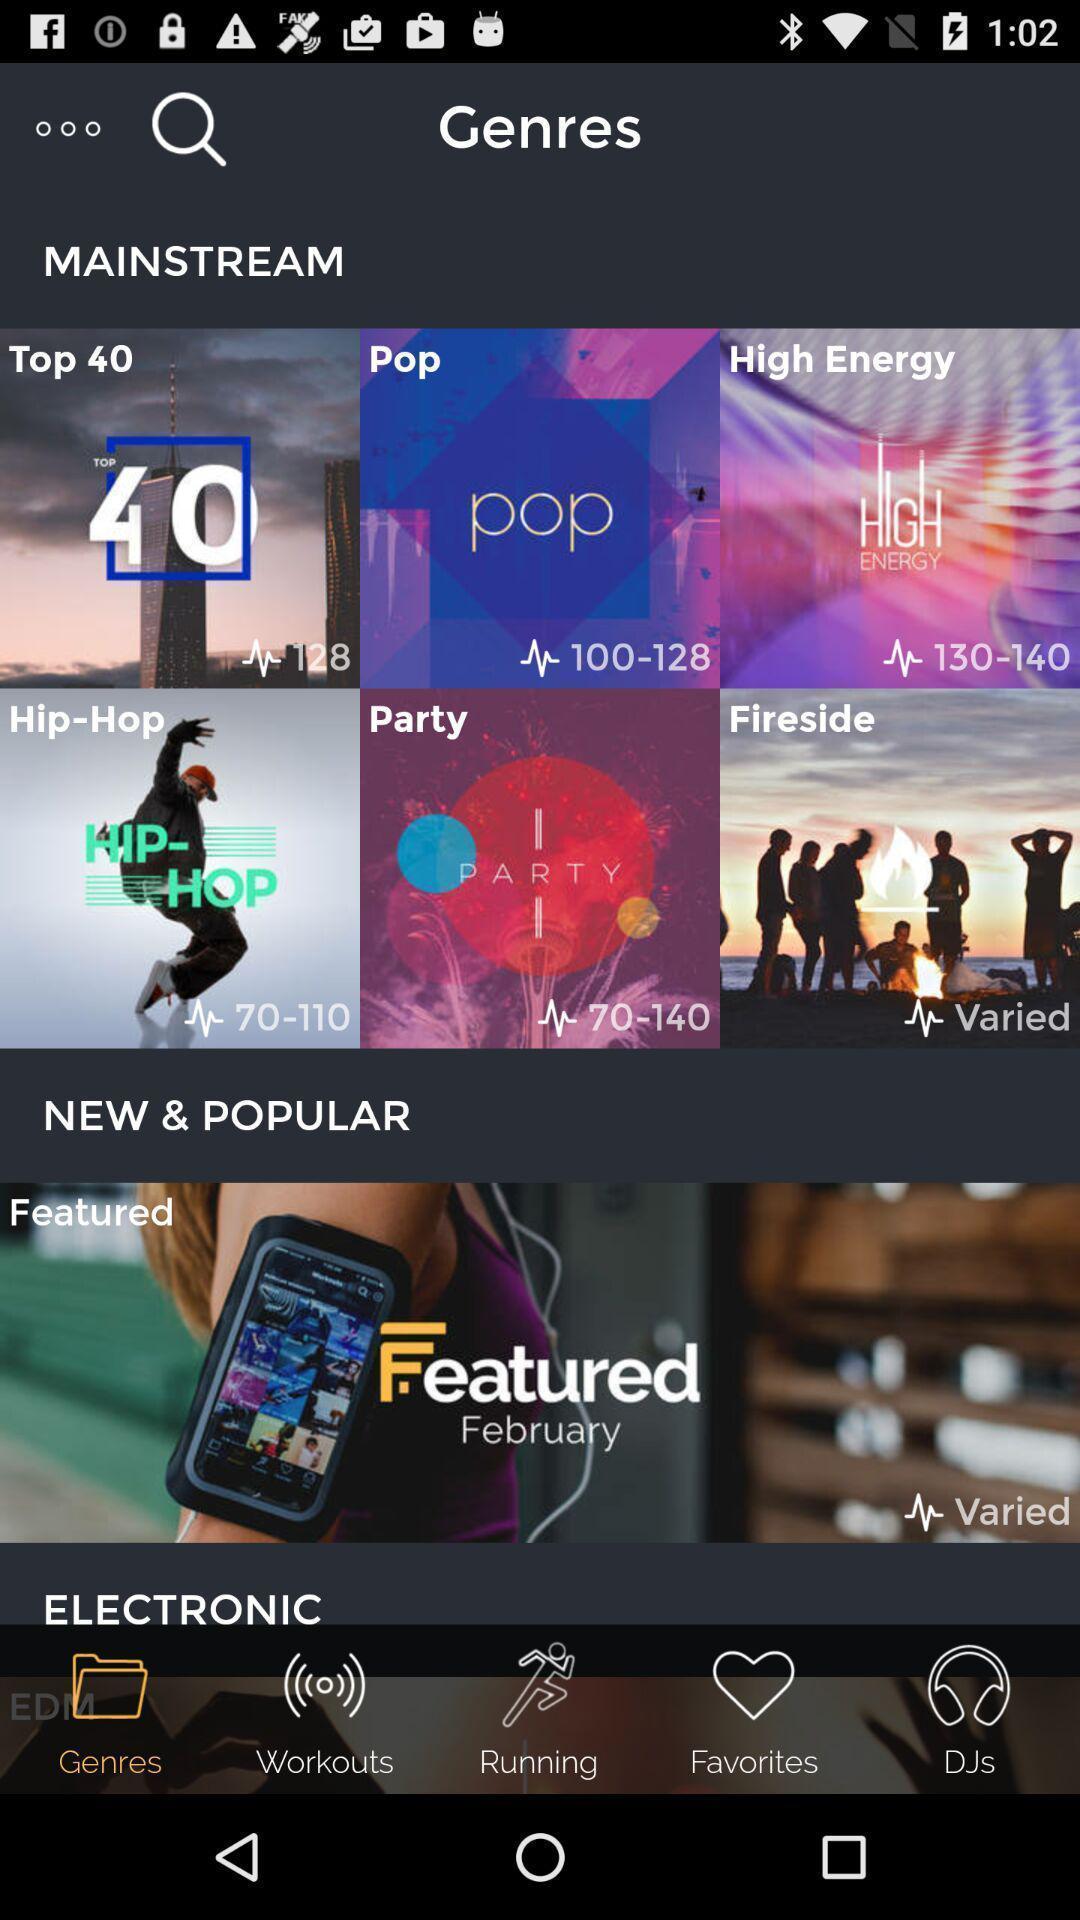Tell me about the visual elements in this screen capture. Screen shows about main stream genres. 